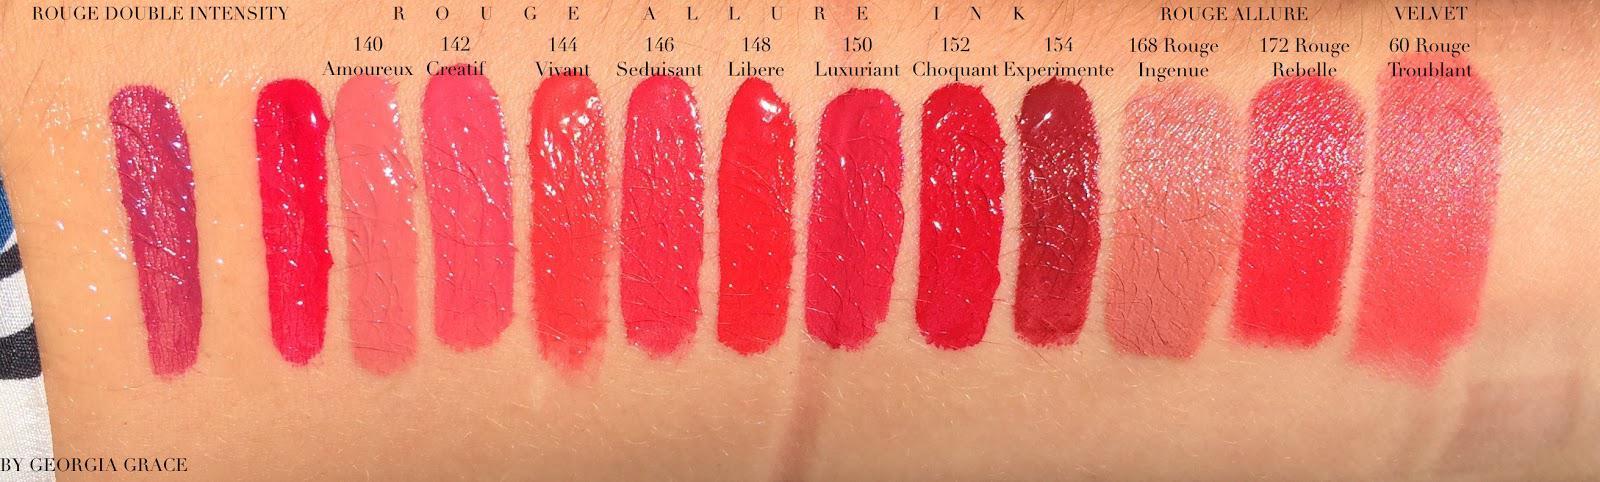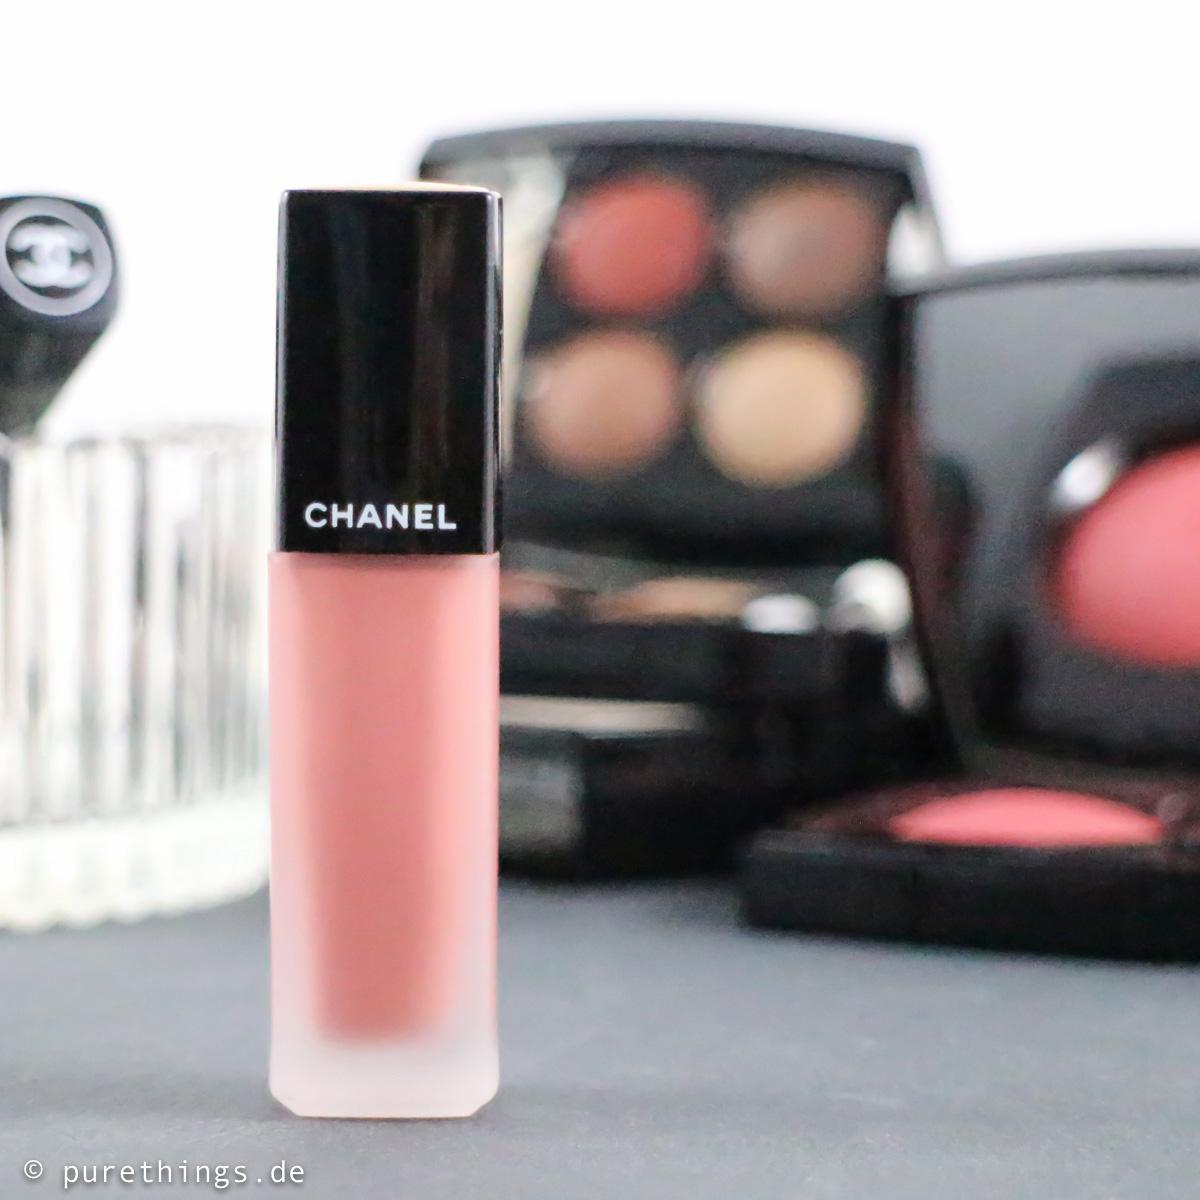The first image is the image on the left, the second image is the image on the right. Given the left and right images, does the statement "The left image shows a lipstick color test on a person's wrist area." hold true? Answer yes or no. No. 